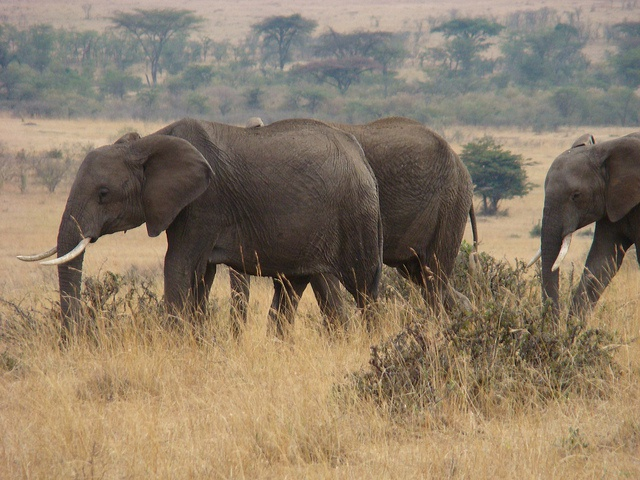Describe the objects in this image and their specific colors. I can see elephant in darkgray, black, and gray tones, elephant in darkgray, gray, and black tones, and elephant in darkgray, black, and gray tones in this image. 